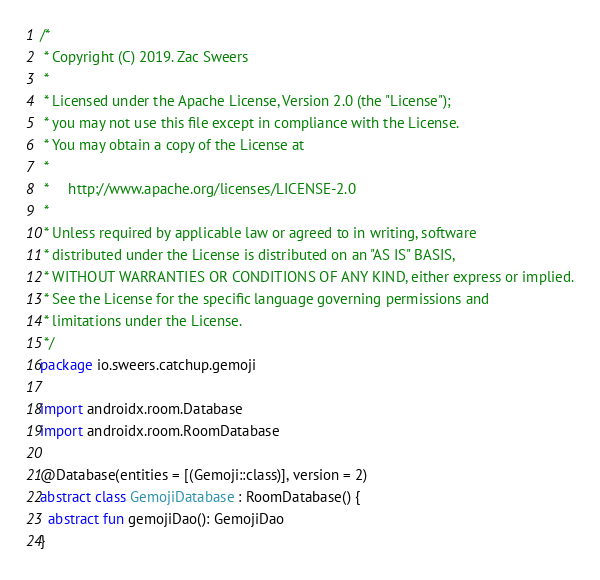<code> <loc_0><loc_0><loc_500><loc_500><_Kotlin_>/*
 * Copyright (C) 2019. Zac Sweers
 *
 * Licensed under the Apache License, Version 2.0 (the "License");
 * you may not use this file except in compliance with the License.
 * You may obtain a copy of the License at
 *
 *     http://www.apache.org/licenses/LICENSE-2.0
 *
 * Unless required by applicable law or agreed to in writing, software
 * distributed under the License is distributed on an "AS IS" BASIS,
 * WITHOUT WARRANTIES OR CONDITIONS OF ANY KIND, either express or implied.
 * See the License for the specific language governing permissions and
 * limitations under the License.
 */
package io.sweers.catchup.gemoji

import androidx.room.Database
import androidx.room.RoomDatabase

@Database(entities = [(Gemoji::class)], version = 2)
abstract class GemojiDatabase : RoomDatabase() {
  abstract fun gemojiDao(): GemojiDao
}
</code> 